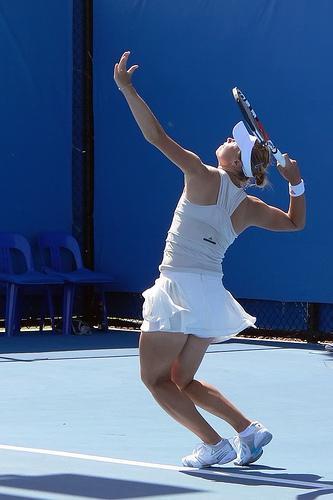How many people are in this photo?
Give a very brief answer. 1. 